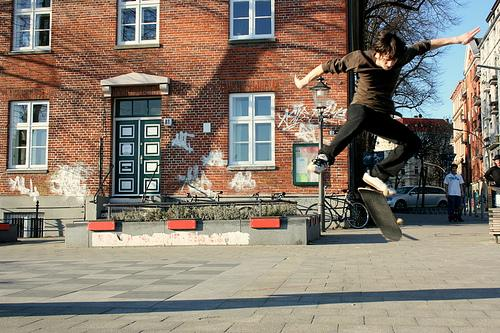The concrete planter has how many orange boards on the side? Please explain your reasoning. three. There are three parts to it. 